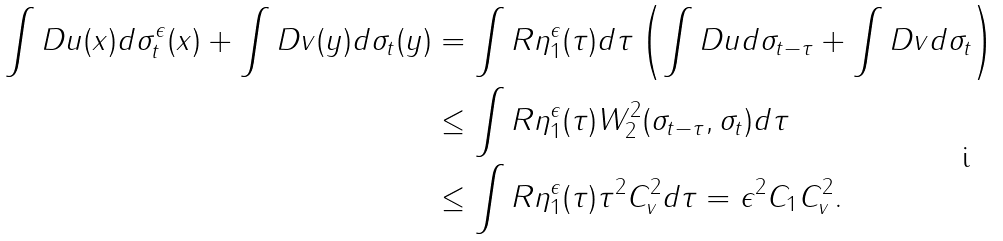<formula> <loc_0><loc_0><loc_500><loc_500>\int D u ( x ) d \sigma ^ { \epsilon } _ { t } ( x ) + \int D v ( y ) d \sigma _ { t } ( y ) & = \int R \eta ^ { \epsilon } _ { 1 } ( \tau ) d \tau \left ( \int D u d \sigma _ { t - \tau } + \int D v d \sigma _ { t } \right ) \\ & \leq \int R \eta ^ { \epsilon } _ { 1 } ( \tau ) W _ { 2 } ^ { 2 } ( \sigma _ { t - \tau } , \sigma _ { t } ) d \tau \\ & \leq \int R \eta ^ { \epsilon } _ { 1 } ( \tau ) \tau ^ { 2 } C _ { v } ^ { 2 } d \tau = \epsilon ^ { 2 } C _ { 1 } C _ { v } ^ { 2 } .</formula> 